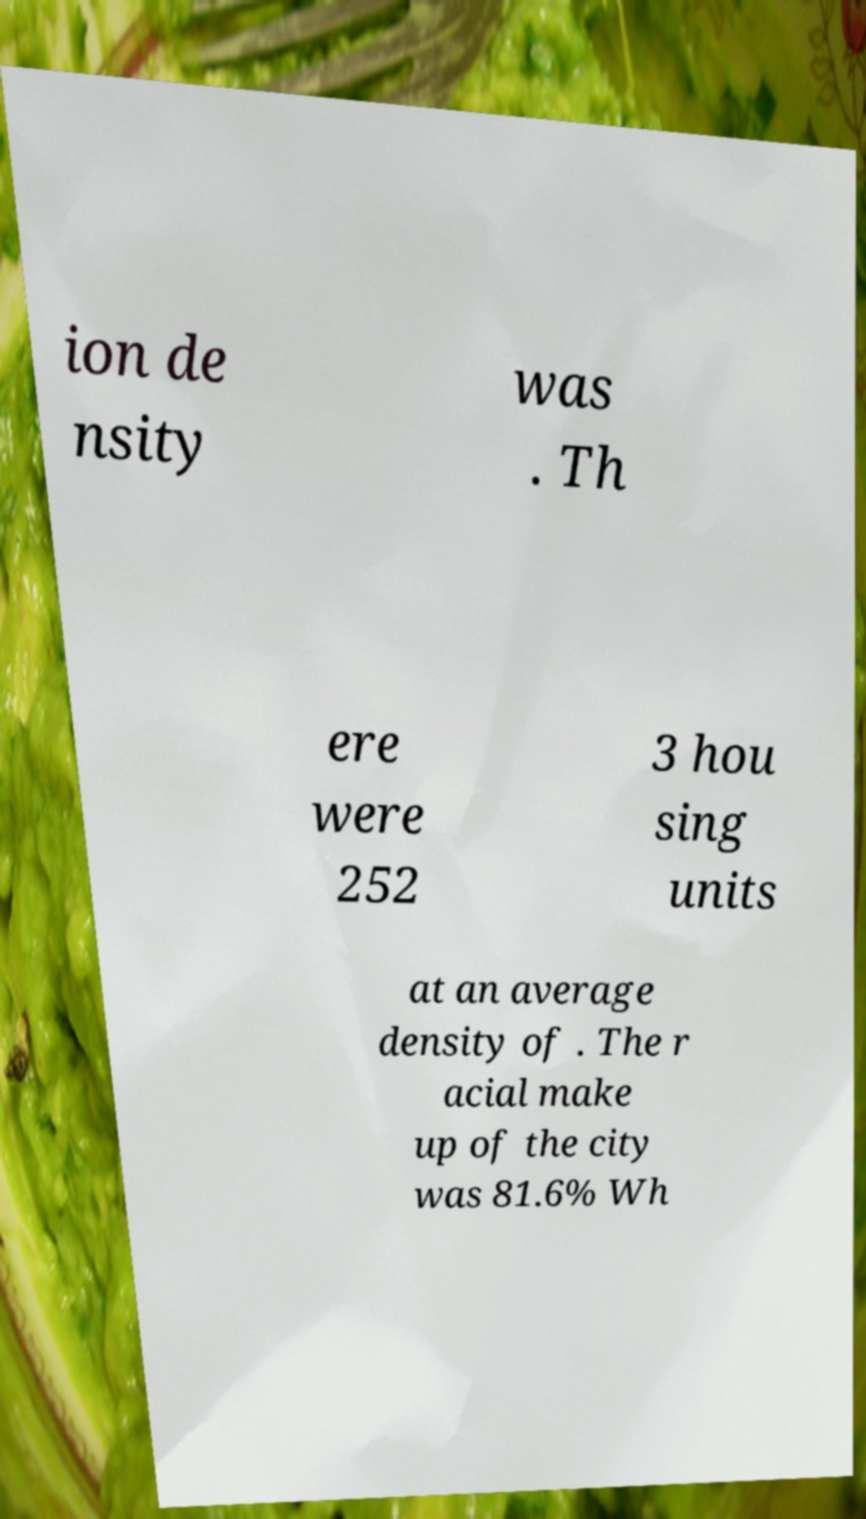For documentation purposes, I need the text within this image transcribed. Could you provide that? ion de nsity was . Th ere were 252 3 hou sing units at an average density of . The r acial make up of the city was 81.6% Wh 